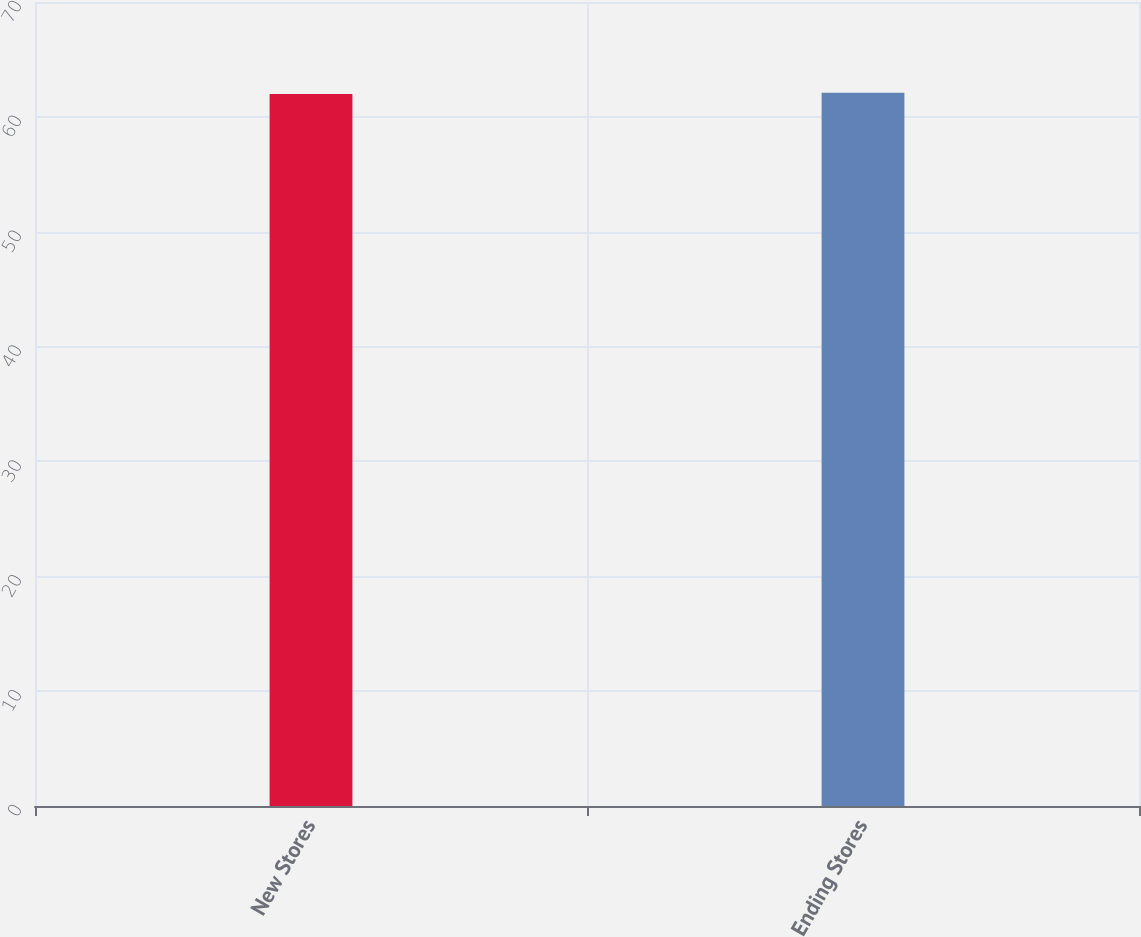Convert chart. <chart><loc_0><loc_0><loc_500><loc_500><bar_chart><fcel>New Stores<fcel>Ending Stores<nl><fcel>62<fcel>62.1<nl></chart> 